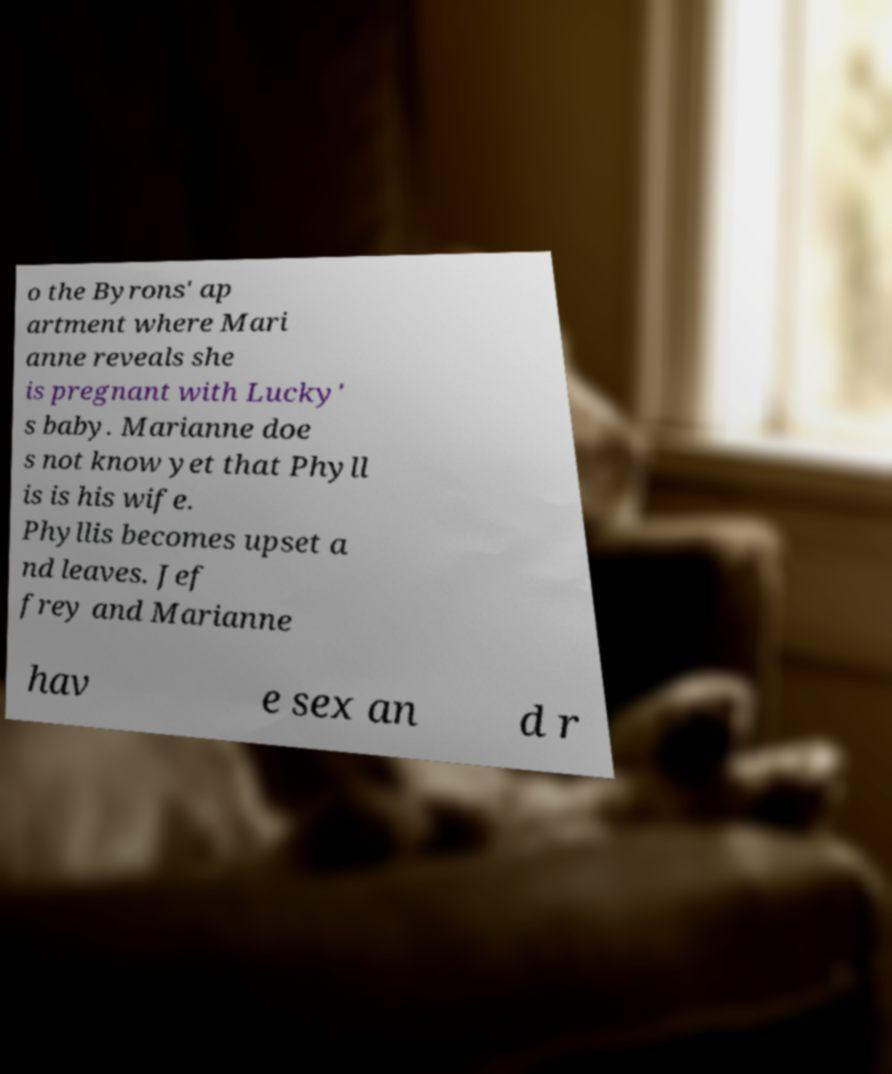Could you assist in decoding the text presented in this image and type it out clearly? o the Byrons' ap artment where Mari anne reveals she is pregnant with Lucky' s baby. Marianne doe s not know yet that Phyll is is his wife. Phyllis becomes upset a nd leaves. Jef frey and Marianne hav e sex an d r 